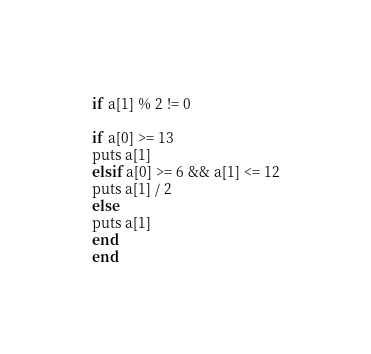<code> <loc_0><loc_0><loc_500><loc_500><_Ruby_>if a[1] % 2 != 0

if a[0] >= 13
puts a[1]
elsif a[0] >= 6 && a[1] <= 12
puts a[1] / 2
else
puts a[1]
end
end</code> 